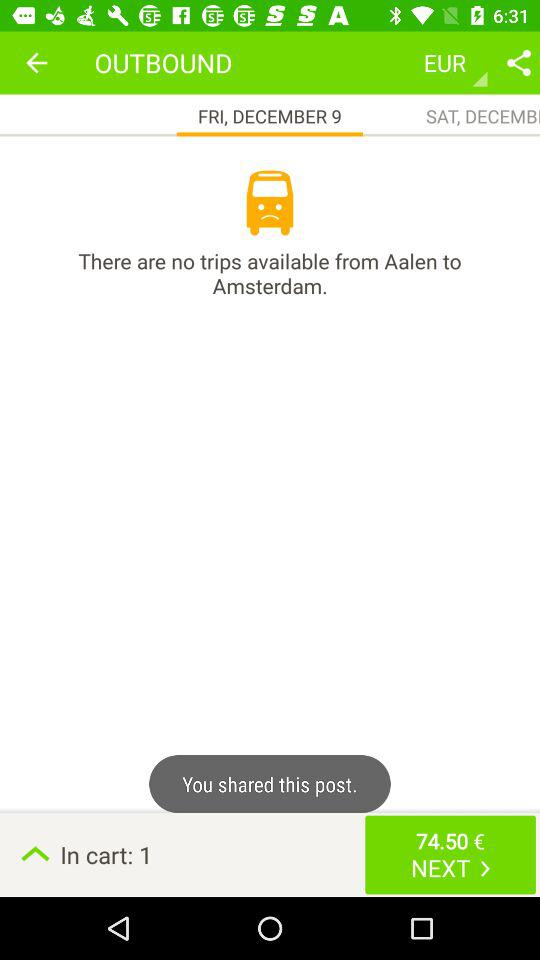What is the date for the outbound trip? The date for the outbound trip is Friday, December 9. 